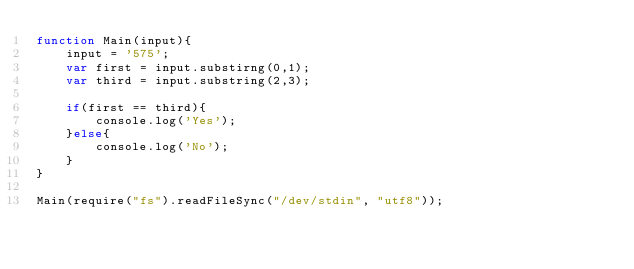<code> <loc_0><loc_0><loc_500><loc_500><_JavaScript_>function Main(input){
    input = '575';
    var first = input.substirng(0,1);
    var third = input.substring(2,3);

    if(first == third){
        console.log('Yes');
    }else{
        console.log('No');
    }
}

Main(require("fs").readFileSync("/dev/stdin", "utf8"));
</code> 